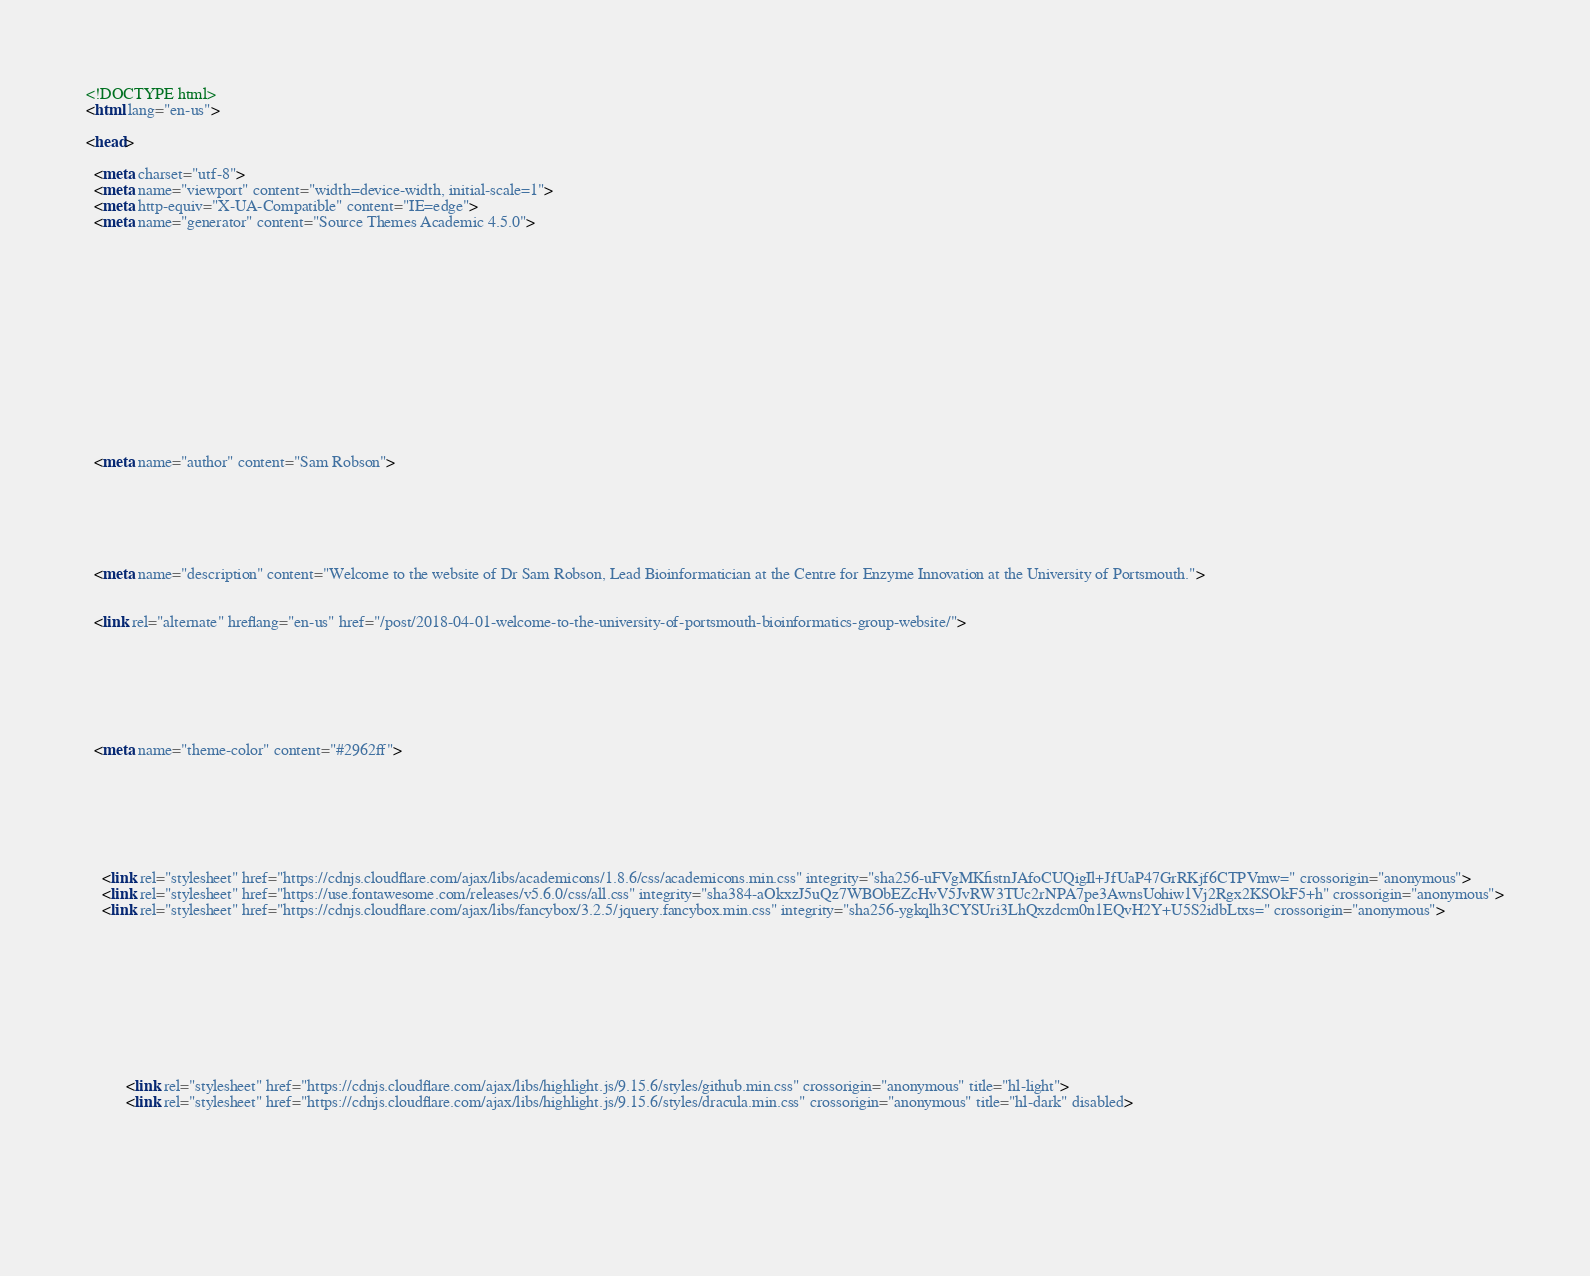Convert code to text. <code><loc_0><loc_0><loc_500><loc_500><_HTML_><!DOCTYPE html>
<html lang="en-us">

<head>

  <meta charset="utf-8">
  <meta name="viewport" content="width=device-width, initial-scale=1">
  <meta http-equiv="X-UA-Compatible" content="IE=edge">
  <meta name="generator" content="Source Themes Academic 4.5.0">

  

  
  
  
  
  
    
    
    
  
  

  <meta name="author" content="Sam Robson">

  
  
  
    
  
  <meta name="description" content="Welcome to the website of Dr Sam Robson, Lead Bioinformatician at the Centre for Enzyme Innovation at the University of Portsmouth.">

  
  <link rel="alternate" hreflang="en-us" href="/post/2018-04-01-welcome-to-the-university-of-portsmouth-bioinformatics-group-website/">

  


  
  
  
  <meta name="theme-color" content="#2962ff">
  

  
  
  
  
    
    <link rel="stylesheet" href="https://cdnjs.cloudflare.com/ajax/libs/academicons/1.8.6/css/academicons.min.css" integrity="sha256-uFVgMKfistnJAfoCUQigIl+JfUaP47GrRKjf6CTPVmw=" crossorigin="anonymous">
    <link rel="stylesheet" href="https://use.fontawesome.com/releases/v5.6.0/css/all.css" integrity="sha384-aOkxzJ5uQz7WBObEZcHvV5JvRW3TUc2rNPA7pe3AwnsUohiw1Vj2Rgx2KSOkF5+h" crossorigin="anonymous">
    <link rel="stylesheet" href="https://cdnjs.cloudflare.com/ajax/libs/fancybox/3.2.5/jquery.fancybox.min.css" integrity="sha256-ygkqlh3CYSUri3LhQxzdcm0n1EQvH2Y+U5S2idbLtxs=" crossorigin="anonymous">

    
    
    
      
    
    
      
      
        
          <link rel="stylesheet" href="https://cdnjs.cloudflare.com/ajax/libs/highlight.js/9.15.6/styles/github.min.css" crossorigin="anonymous" title="hl-light">
          <link rel="stylesheet" href="https://cdnjs.cloudflare.com/ajax/libs/highlight.js/9.15.6/styles/dracula.min.css" crossorigin="anonymous" title="hl-dark" disabled>
        
      
    

    </code> 